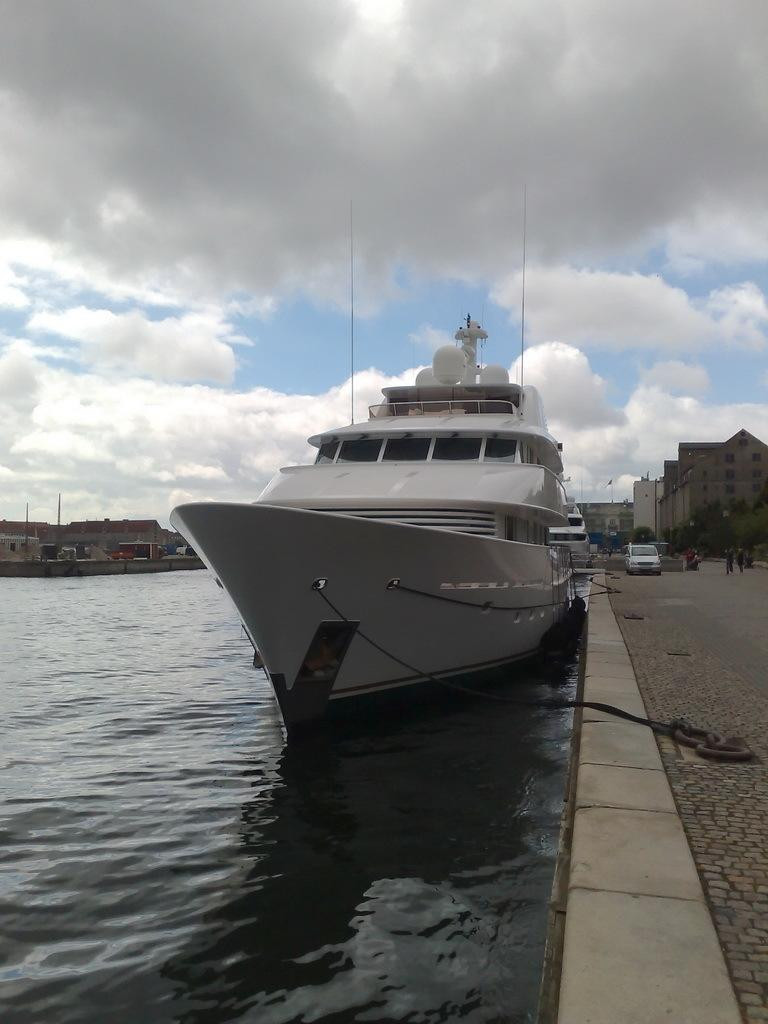What is the main subject of the image? The main subject of the image is a ship. Where is the ship located? The ship is on a river. What can be seen in the background of the image? There are buildings, trees, and vehicles on the road in the background of the image. What is visible in the sky at the top of the image? There are clouds visible in the sky at the top of the image. What type of corn is growing on the ship's deck in the image? There is no corn present on the ship's deck in the image. 